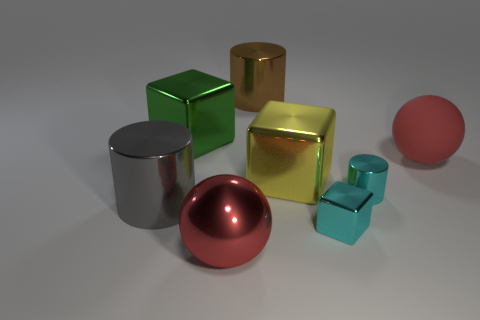How many cylinders are the same color as the small shiny block?
Make the answer very short. 1. What is the material of the small cylinder that is the same color as the small metal cube?
Offer a very short reply. Metal. What size is the red sphere that is in front of the yellow object that is in front of the brown metal thing?
Your response must be concise. Large. Are there any other cyan cylinders that have the same material as the cyan cylinder?
Keep it short and to the point. No. What material is the brown cylinder that is the same size as the gray metallic cylinder?
Keep it short and to the point. Metal. There is a big shiny cylinder behind the tiny cyan cylinder; does it have the same color as the large ball that is on the right side of the large shiny sphere?
Provide a succinct answer. No. Is there a large cylinder to the left of the large shiny object that is left of the large green metal thing?
Give a very brief answer. No. There is a big red object that is behind the large yellow metal cube; is it the same shape as the red thing to the left of the red matte sphere?
Offer a very short reply. Yes. Do the large ball on the right side of the big yellow metallic cube and the cylinder in front of the cyan cylinder have the same material?
Your answer should be very brief. No. The cylinder that is to the left of the big red ball that is to the left of the large yellow shiny block is made of what material?
Provide a succinct answer. Metal. 